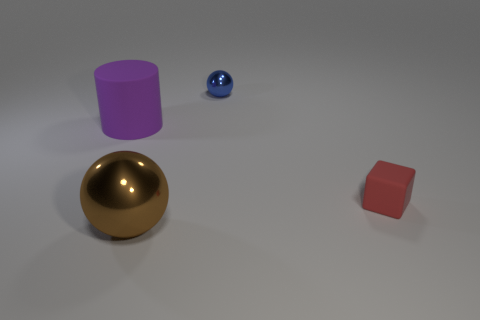How many tiny spheres are the same color as the block? Upon examining the image, there appears to be one tiny sphere and it is blue, which does not match the red color of the cube-shaped block. Therefore, there are no tiny spheres that are the same color as the block. 